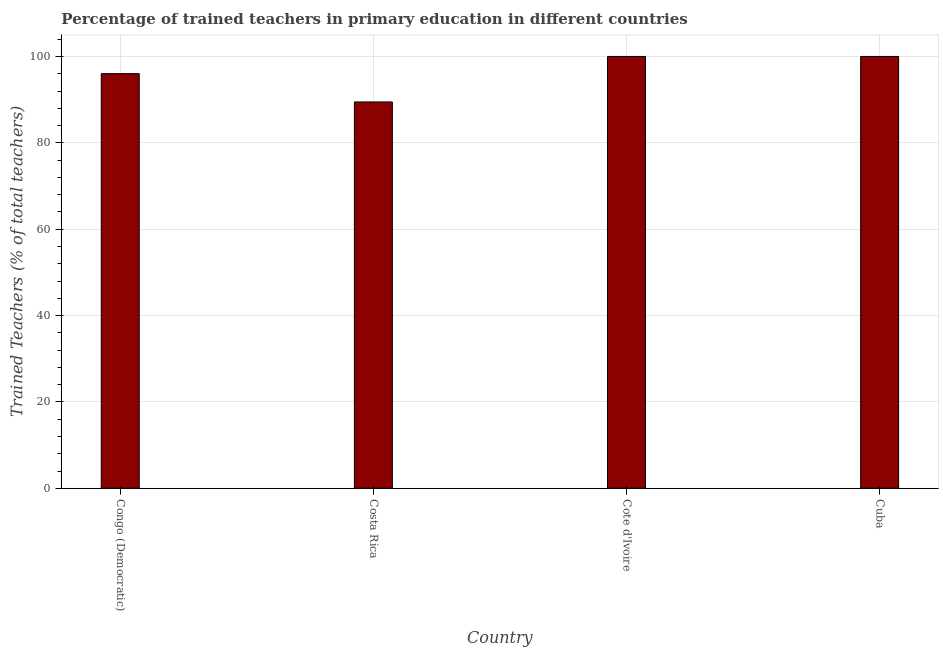Does the graph contain grids?
Your answer should be very brief. Yes. What is the title of the graph?
Make the answer very short. Percentage of trained teachers in primary education in different countries. What is the label or title of the X-axis?
Ensure brevity in your answer.  Country. What is the label or title of the Y-axis?
Your response must be concise. Trained Teachers (% of total teachers). What is the percentage of trained teachers in Congo (Democratic)?
Provide a succinct answer. 96.02. Across all countries, what is the maximum percentage of trained teachers?
Ensure brevity in your answer.  100. Across all countries, what is the minimum percentage of trained teachers?
Give a very brief answer. 89.47. In which country was the percentage of trained teachers maximum?
Offer a very short reply. Cote d'Ivoire. In which country was the percentage of trained teachers minimum?
Give a very brief answer. Costa Rica. What is the sum of the percentage of trained teachers?
Give a very brief answer. 385.49. What is the difference between the percentage of trained teachers in Congo (Democratic) and Cote d'Ivoire?
Offer a terse response. -3.98. What is the average percentage of trained teachers per country?
Your answer should be compact. 96.37. What is the median percentage of trained teachers?
Offer a very short reply. 98.01. In how many countries, is the percentage of trained teachers greater than 28 %?
Provide a succinct answer. 4. Is the percentage of trained teachers in Costa Rica less than that in Cote d'Ivoire?
Offer a very short reply. Yes. Is the difference between the percentage of trained teachers in Costa Rica and Cuba greater than the difference between any two countries?
Your answer should be very brief. Yes. What is the difference between the highest and the second highest percentage of trained teachers?
Your answer should be very brief. 0. Is the sum of the percentage of trained teachers in Cote d'Ivoire and Cuba greater than the maximum percentage of trained teachers across all countries?
Make the answer very short. Yes. What is the difference between the highest and the lowest percentage of trained teachers?
Ensure brevity in your answer.  10.53. How many bars are there?
Give a very brief answer. 4. Are all the bars in the graph horizontal?
Give a very brief answer. No. What is the Trained Teachers (% of total teachers) of Congo (Democratic)?
Give a very brief answer. 96.02. What is the Trained Teachers (% of total teachers) of Costa Rica?
Provide a short and direct response. 89.47. What is the Trained Teachers (% of total teachers) of Cote d'Ivoire?
Your answer should be compact. 100. What is the Trained Teachers (% of total teachers) of Cuba?
Your response must be concise. 100. What is the difference between the Trained Teachers (% of total teachers) in Congo (Democratic) and Costa Rica?
Offer a terse response. 6.56. What is the difference between the Trained Teachers (% of total teachers) in Congo (Democratic) and Cote d'Ivoire?
Offer a very short reply. -3.98. What is the difference between the Trained Teachers (% of total teachers) in Congo (Democratic) and Cuba?
Offer a terse response. -3.98. What is the difference between the Trained Teachers (% of total teachers) in Costa Rica and Cote d'Ivoire?
Keep it short and to the point. -10.53. What is the difference between the Trained Teachers (% of total teachers) in Costa Rica and Cuba?
Your answer should be very brief. -10.53. What is the difference between the Trained Teachers (% of total teachers) in Cote d'Ivoire and Cuba?
Make the answer very short. 0. What is the ratio of the Trained Teachers (% of total teachers) in Congo (Democratic) to that in Costa Rica?
Offer a very short reply. 1.07. What is the ratio of the Trained Teachers (% of total teachers) in Congo (Democratic) to that in Cuba?
Ensure brevity in your answer.  0.96. What is the ratio of the Trained Teachers (% of total teachers) in Costa Rica to that in Cote d'Ivoire?
Keep it short and to the point. 0.9. What is the ratio of the Trained Teachers (% of total teachers) in Costa Rica to that in Cuba?
Offer a terse response. 0.9. 